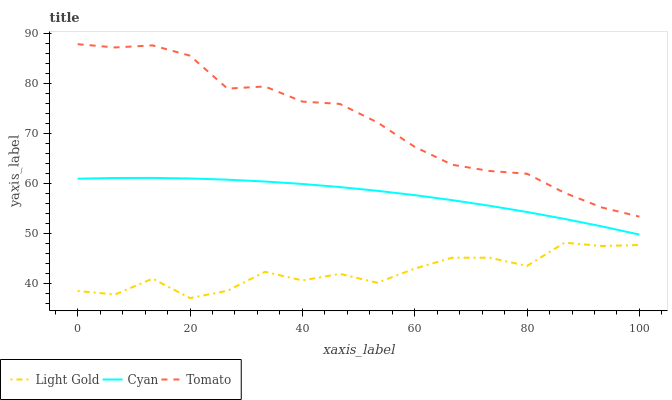Does Light Gold have the minimum area under the curve?
Answer yes or no. Yes. Does Tomato have the maximum area under the curve?
Answer yes or no. Yes. Does Cyan have the minimum area under the curve?
Answer yes or no. No. Does Cyan have the maximum area under the curve?
Answer yes or no. No. Is Cyan the smoothest?
Answer yes or no. Yes. Is Light Gold the roughest?
Answer yes or no. Yes. Is Light Gold the smoothest?
Answer yes or no. No. Is Cyan the roughest?
Answer yes or no. No. Does Light Gold have the lowest value?
Answer yes or no. Yes. Does Cyan have the lowest value?
Answer yes or no. No. Does Tomato have the highest value?
Answer yes or no. Yes. Does Cyan have the highest value?
Answer yes or no. No. Is Light Gold less than Tomato?
Answer yes or no. Yes. Is Tomato greater than Light Gold?
Answer yes or no. Yes. Does Light Gold intersect Tomato?
Answer yes or no. No. 